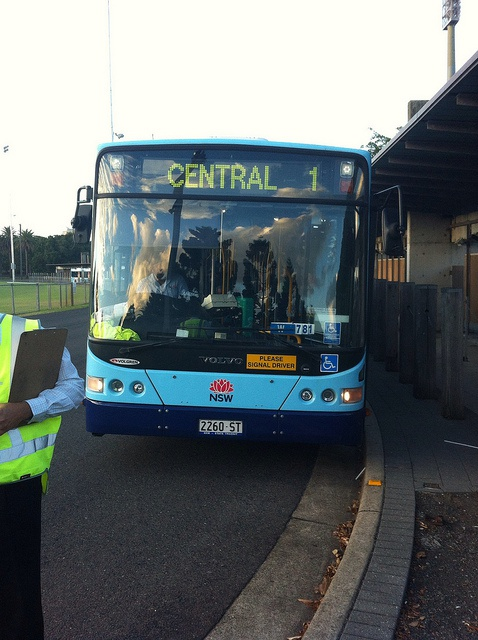Describe the objects in this image and their specific colors. I can see bus in ivory, black, blue, gray, and navy tones, people in ivory, black, lightblue, gray, and green tones, and people in ivory, gray, black, tan, and darkgray tones in this image. 